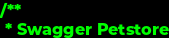Convert code to text. <code><loc_0><loc_0><loc_500><loc_500><_C_>/**
 * Swagger Petstore</code> 